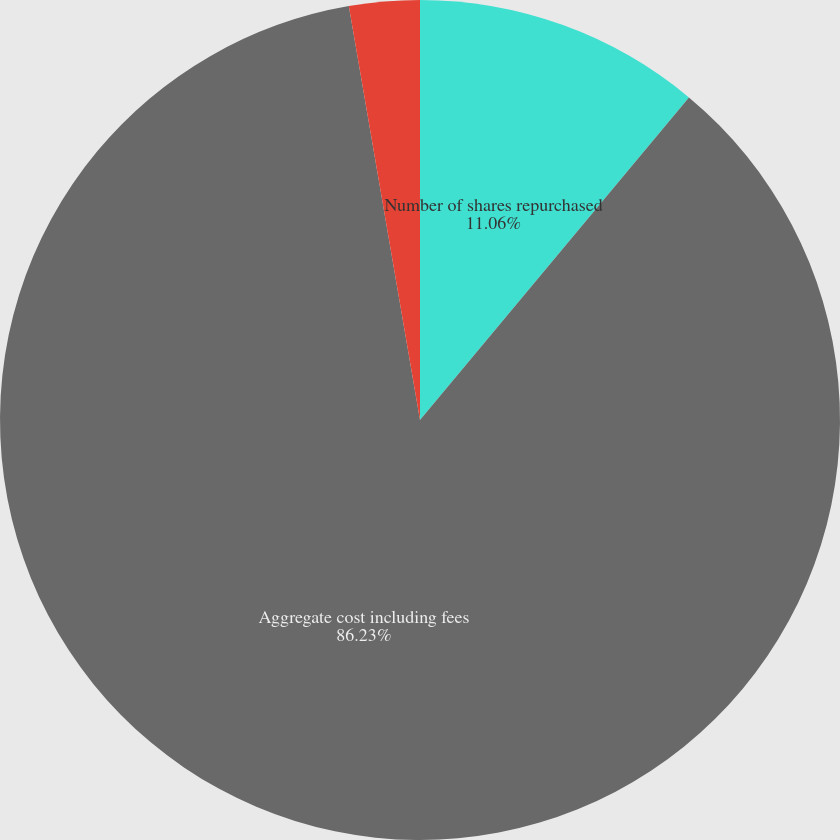<chart> <loc_0><loc_0><loc_500><loc_500><pie_chart><fcel>Number of shares repurchased<fcel>Aggregate cost including fees<fcel>Average price per share<nl><fcel>11.06%<fcel>86.22%<fcel>2.71%<nl></chart> 